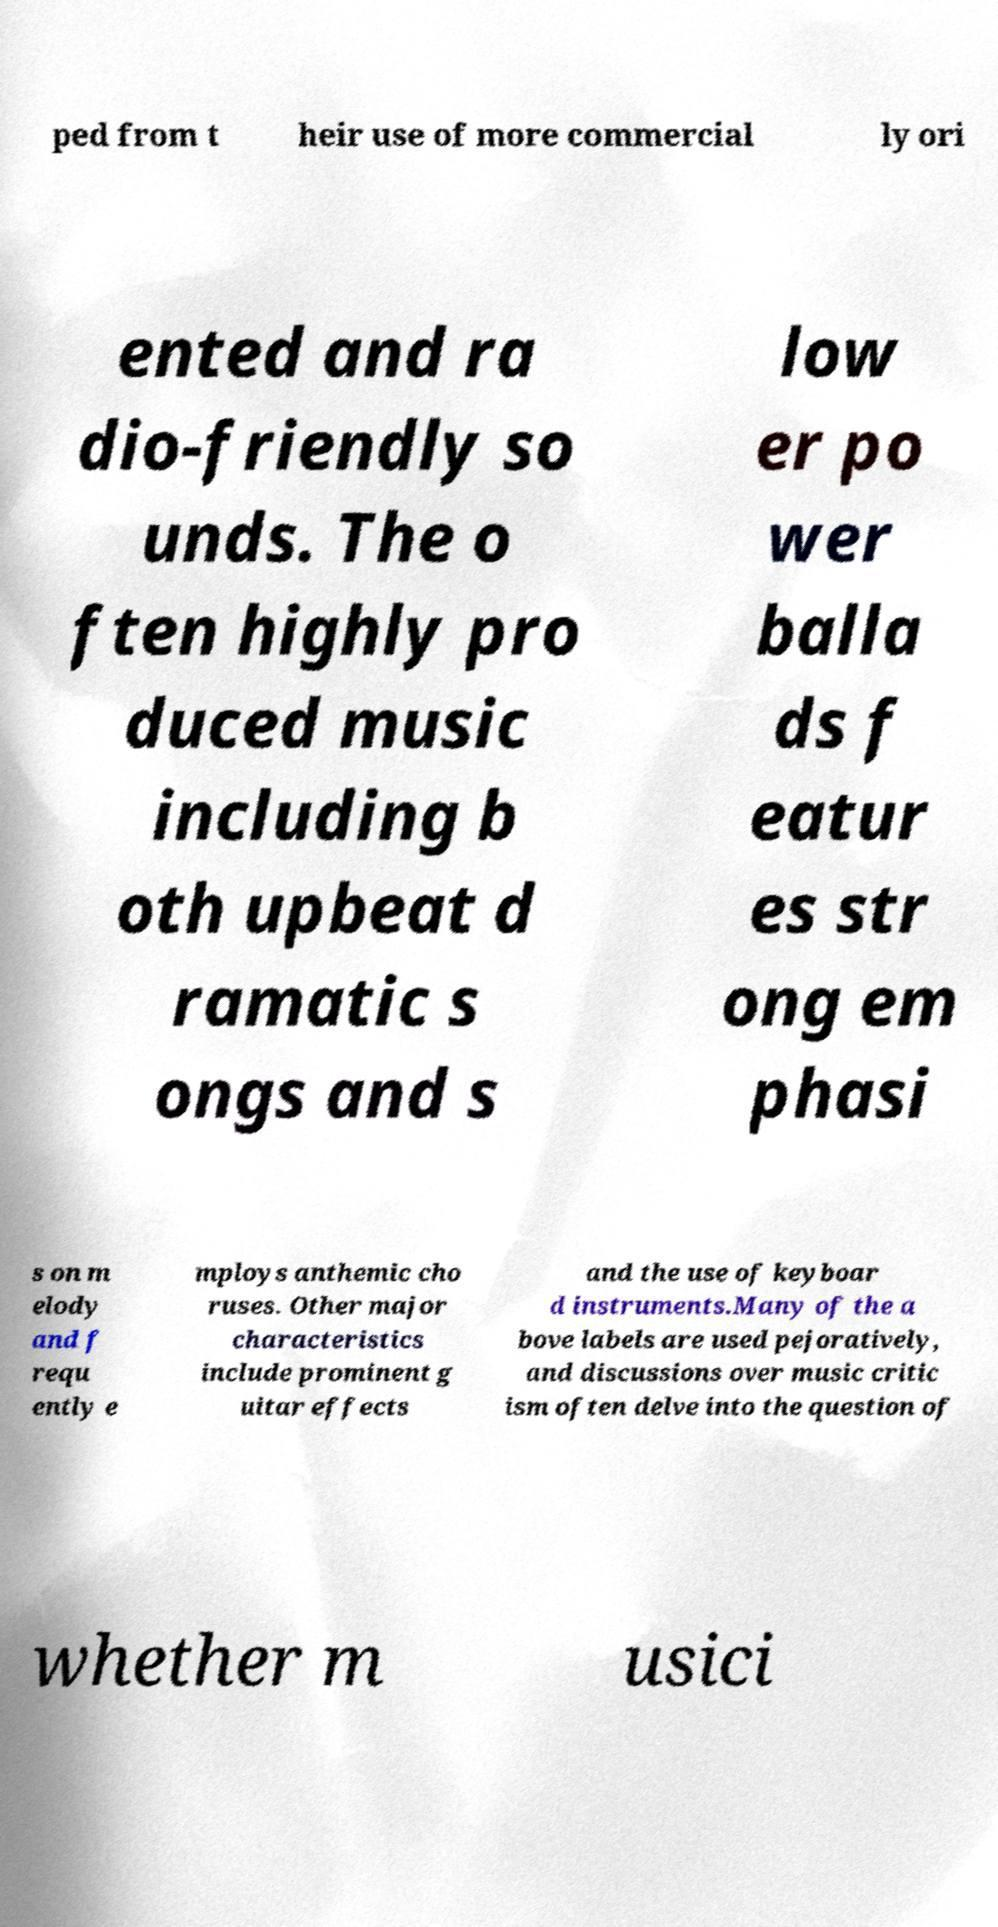Could you assist in decoding the text presented in this image and type it out clearly? ped from t heir use of more commercial ly ori ented and ra dio-friendly so unds. The o ften highly pro duced music including b oth upbeat d ramatic s ongs and s low er po wer balla ds f eatur es str ong em phasi s on m elody and f requ ently e mploys anthemic cho ruses. Other major characteristics include prominent g uitar effects and the use of keyboar d instruments.Many of the a bove labels are used pejoratively, and discussions over music critic ism often delve into the question of whether m usici 